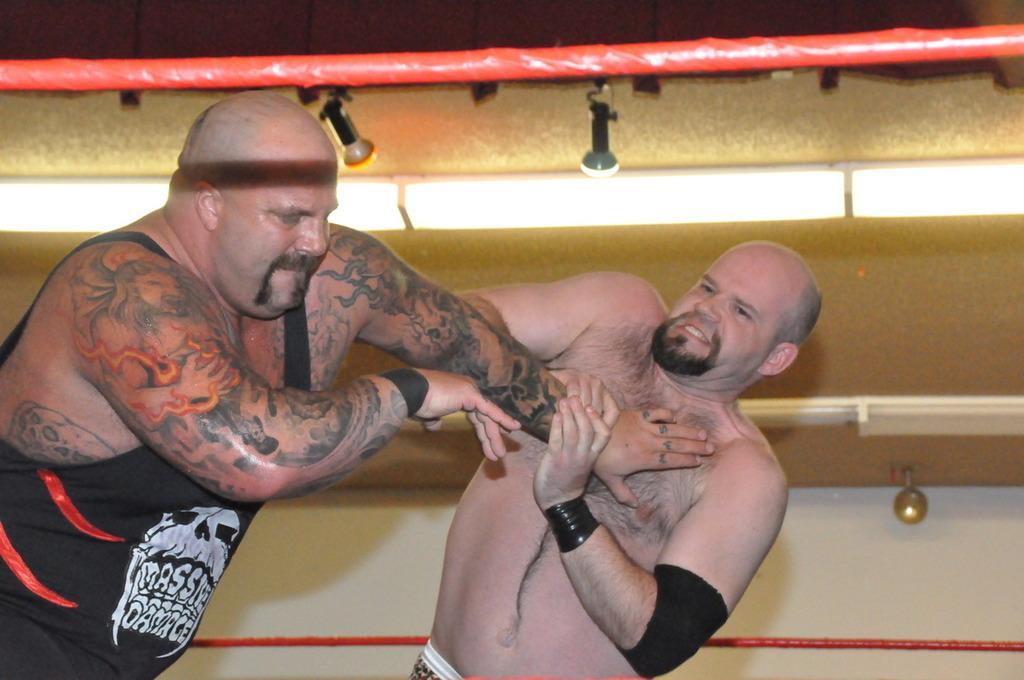Could you give a brief overview of what you see in this image? In this image we can see two persons are fighting. Behind golden and white color wall is there. Top of the image red color rope is present. 